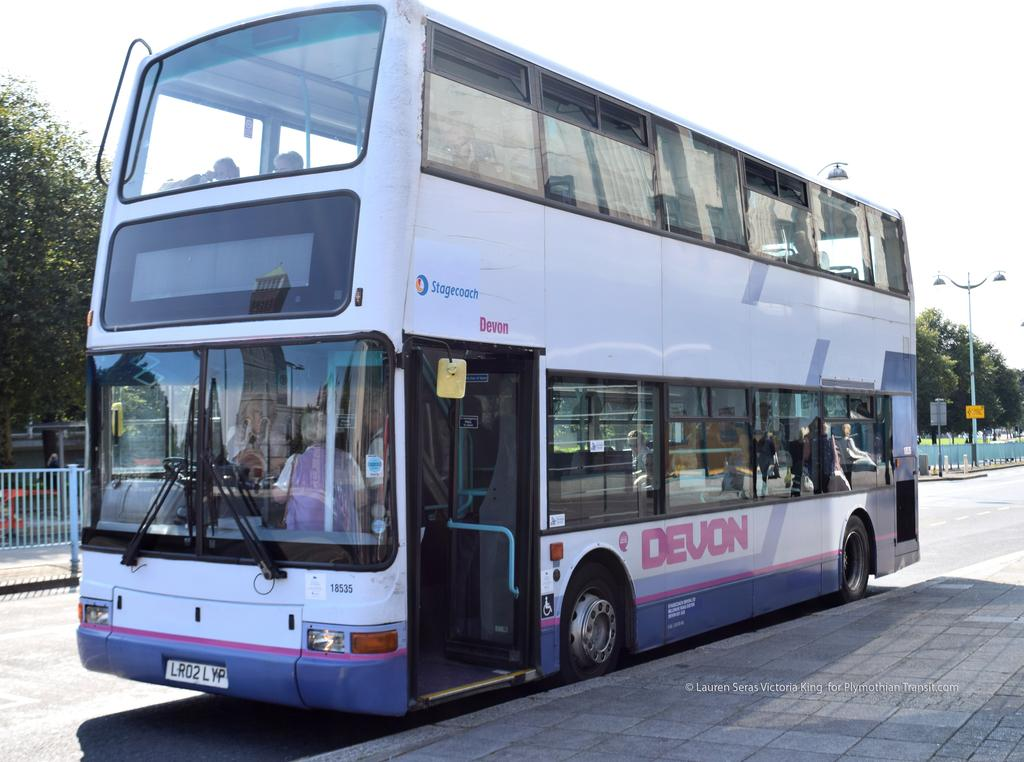<image>
Write a terse but informative summary of the picture. A Devon two level bus is parked on the side of a road. 